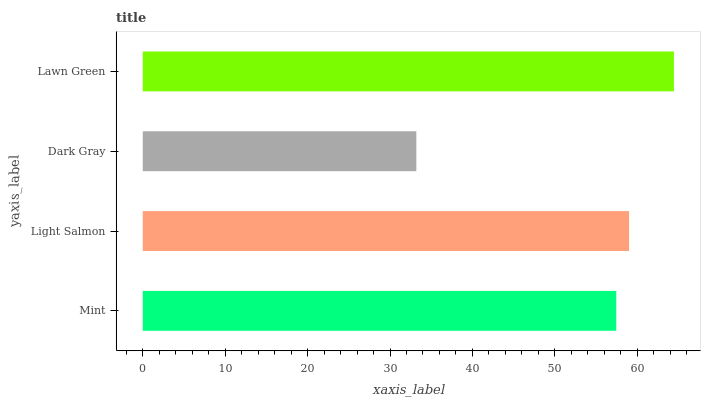Is Dark Gray the minimum?
Answer yes or no. Yes. Is Lawn Green the maximum?
Answer yes or no. Yes. Is Light Salmon the minimum?
Answer yes or no. No. Is Light Salmon the maximum?
Answer yes or no. No. Is Light Salmon greater than Mint?
Answer yes or no. Yes. Is Mint less than Light Salmon?
Answer yes or no. Yes. Is Mint greater than Light Salmon?
Answer yes or no. No. Is Light Salmon less than Mint?
Answer yes or no. No. Is Light Salmon the high median?
Answer yes or no. Yes. Is Mint the low median?
Answer yes or no. Yes. Is Lawn Green the high median?
Answer yes or no. No. Is Light Salmon the low median?
Answer yes or no. No. 